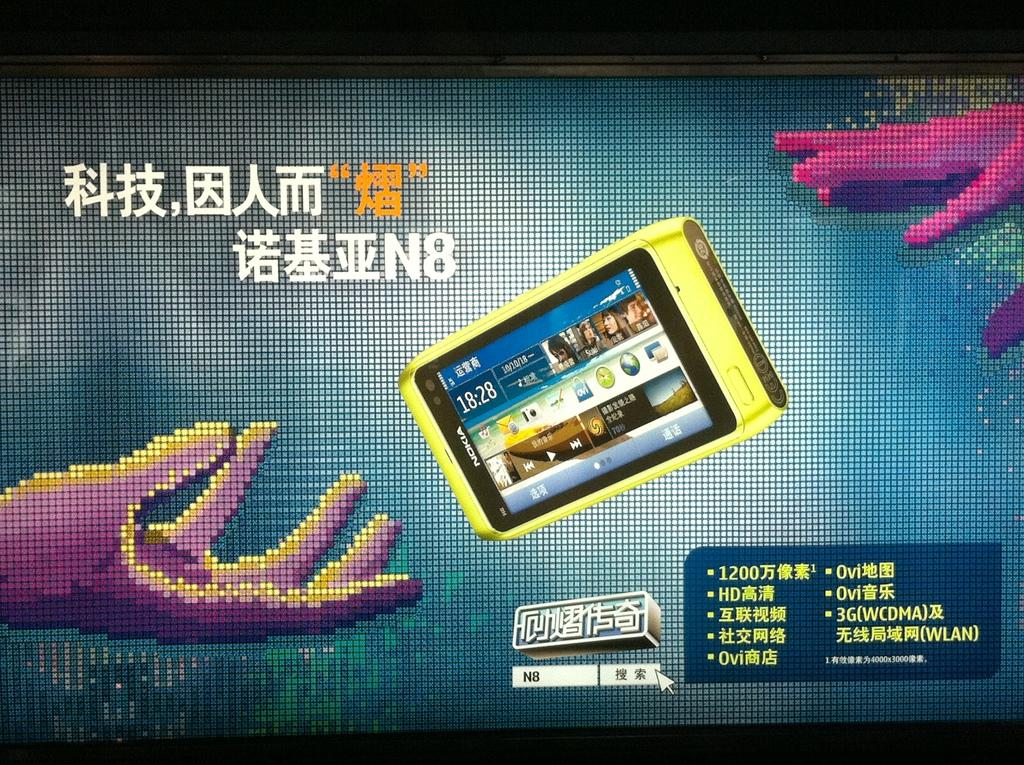<image>
Share a concise interpretation of the image provided. A pixelated display with a yellow Nokia smartphone floating near a hand. 